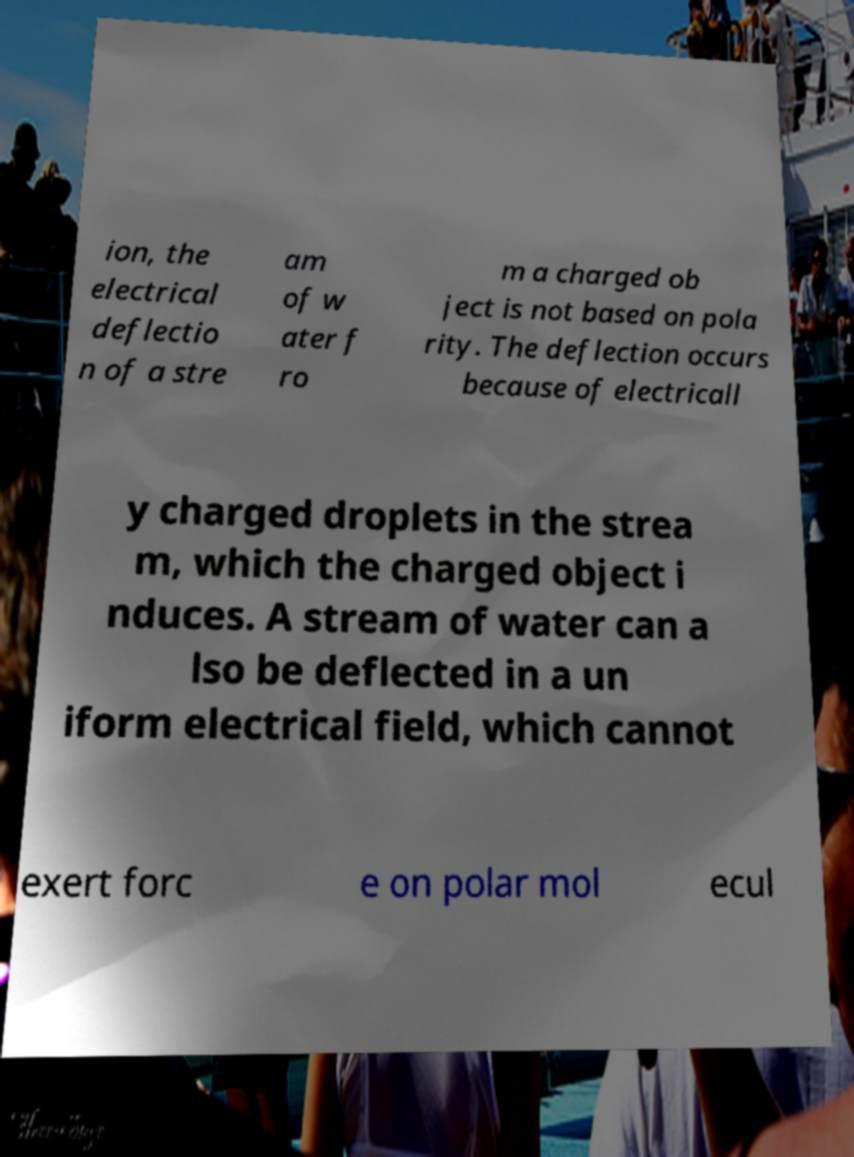Can you read and provide the text displayed in the image?This photo seems to have some interesting text. Can you extract and type it out for me? ion, the electrical deflectio n of a stre am of w ater f ro m a charged ob ject is not based on pola rity. The deflection occurs because of electricall y charged droplets in the strea m, which the charged object i nduces. A stream of water can a lso be deflected in a un iform electrical field, which cannot exert forc e on polar mol ecul 